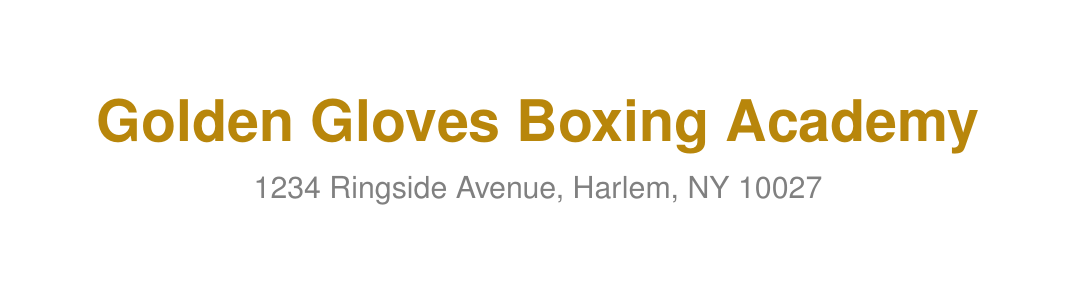what is the name of the scholarship program? The name of the scholarship program is specifically mentioned in the document, which is "Champions of Tomorrow Scholarship Program."
Answer: Champions of Tomorrow Scholarship Program how long is the program duration? The program duration is explicitly stated in the document, which indicates that it lasts for 12 months.
Answer: 12 months who should I contact for more information? The document lists a contact person for inquiries, which is Coach Mike Johnson.
Answer: Coach Mike Johnson what is the application deadline? The document specifies an important date regarding applications, which is August 15, 2023.
Answer: August 15, 2023 what are the ages eligible for the program? The eligibility criteria section provides specific age requirements for applicants, which are ages 14-18.
Answer: Ages 14-18 what is one of the program goals? The document outlines several program goals, and one of them is to develop boxing skills and fitness.
Answer: Develop boxing skills and fitness what equipment is required for participation? The document lists the required equipment for the program, which includes hand wraps, boxing gloves, mouthguard, headgear, jump rope, and athletic shoes.
Answer: Hand wraps, Boxing gloves (14 oz), Mouthguard, Headgear, Jump rope, Athletic shoes which successful participant is mentioned? The document highlights success stories, and one mentioned is Tyrone Williams.
Answer: Tyrone Williams what is the training schedule on weekdays? The training schedule section indicates specific times for training, which for weekdays is 4:00 PM - 6:00 PM.
Answer: 4:00 PM - 6:00 PM 